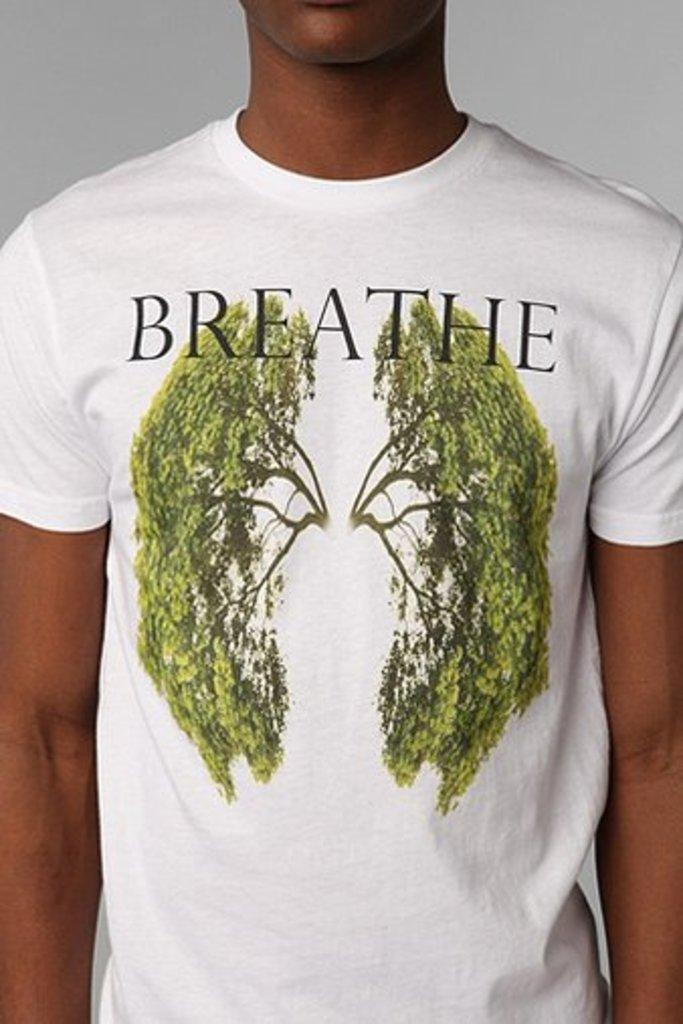Who or what is the main subject in the image? There is a person in the image. What is the person wearing? The person is wearing a white t-shirt. Where is the person located in the image? The person is located in the center of the image. How many boats are visible in the image? There are no boats present in the image. What type of pencil is the person holding in the image? There is no pencil visible in the image. 